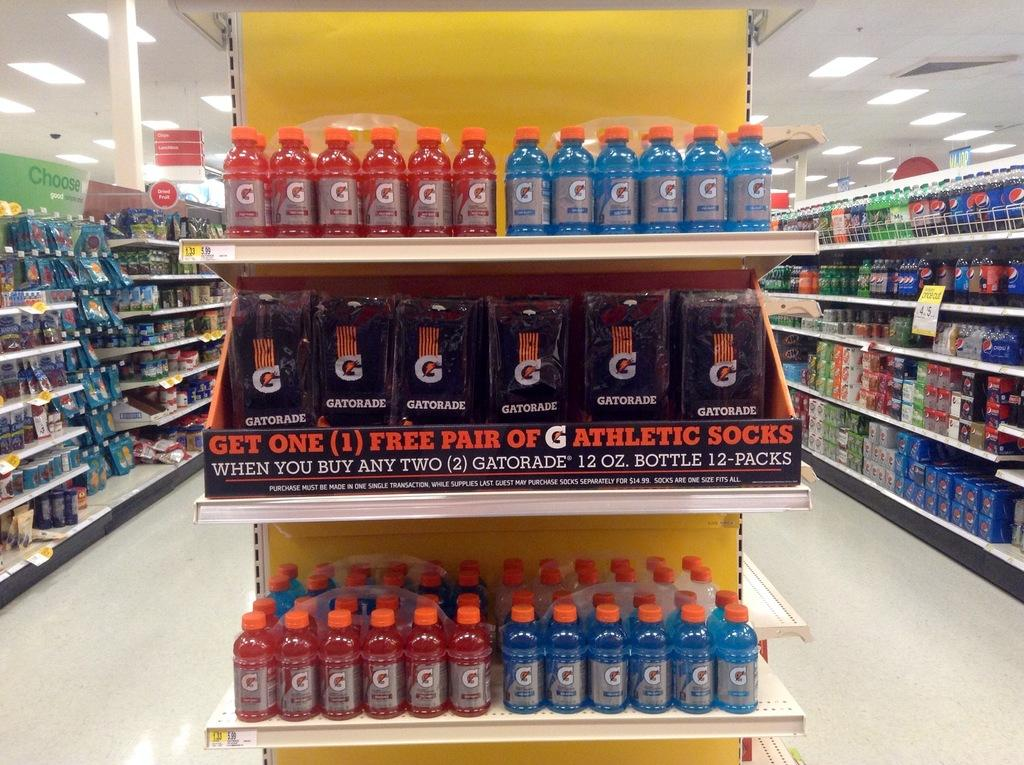Provide a one-sentence caption for the provided image. A supermarket with a shelf display reading: "Get One (1) Free Pair of G Athletic socks.". 